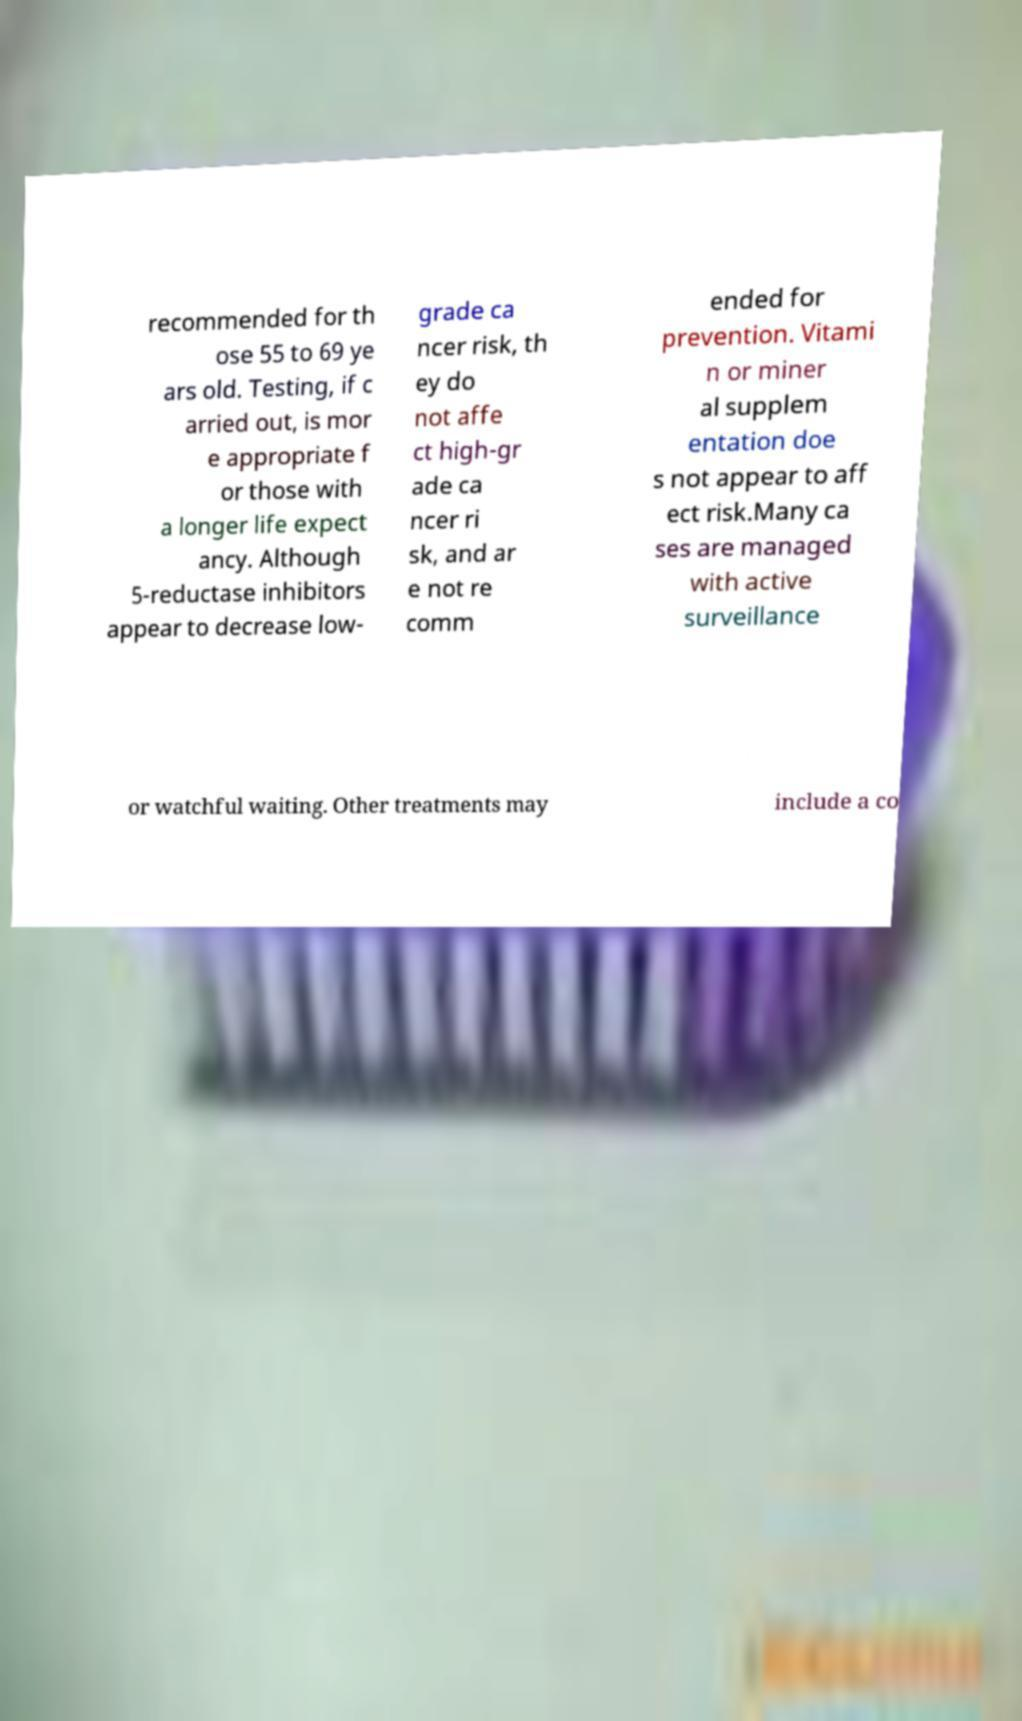I need the written content from this picture converted into text. Can you do that? recommended for th ose 55 to 69 ye ars old. Testing, if c arried out, is mor e appropriate f or those with a longer life expect ancy. Although 5-reductase inhibitors appear to decrease low- grade ca ncer risk, th ey do not affe ct high-gr ade ca ncer ri sk, and ar e not re comm ended for prevention. Vitami n or miner al supplem entation doe s not appear to aff ect risk.Many ca ses are managed with active surveillance or watchful waiting. Other treatments may include a co 